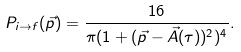<formula> <loc_0><loc_0><loc_500><loc_500>P _ { i \rightarrow f } ( \vec { p } ) = \frac { 1 6 } { \pi ( 1 + ( \vec { p } - \vec { A } ( \tau ) ) ^ { 2 } ) ^ { 4 } } .</formula> 